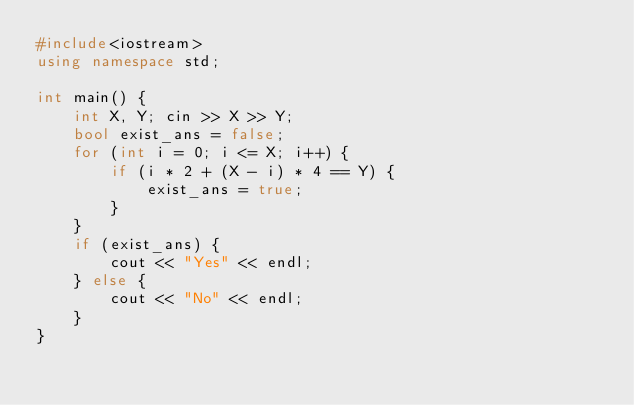<code> <loc_0><loc_0><loc_500><loc_500><_C++_>#include<iostream>
using namespace std;

int main() {
    int X, Y; cin >> X >> Y;
    bool exist_ans = false;
    for (int i = 0; i <= X; i++) {
        if (i * 2 + (X - i) * 4 == Y) {
            exist_ans = true;
        }
    }
    if (exist_ans) {
        cout << "Yes" << endl;
    } else {
        cout << "No" << endl;
    }
}
</code> 